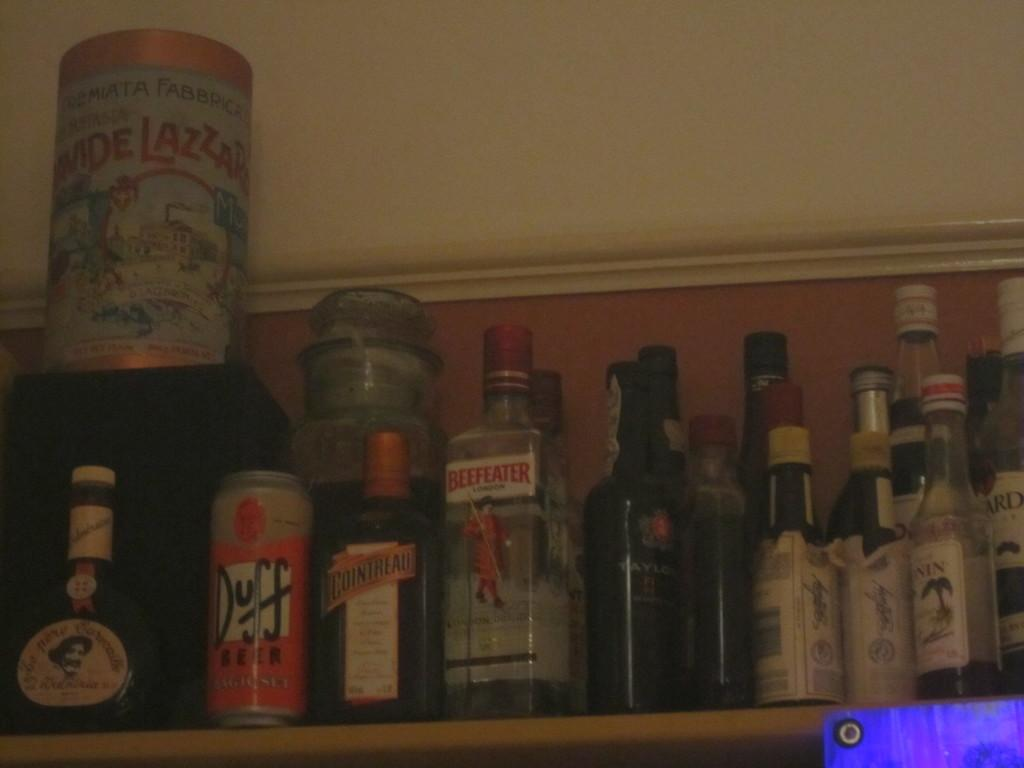<image>
Relay a brief, clear account of the picture shown. Various items on a shelf including a can of Duff beer. 